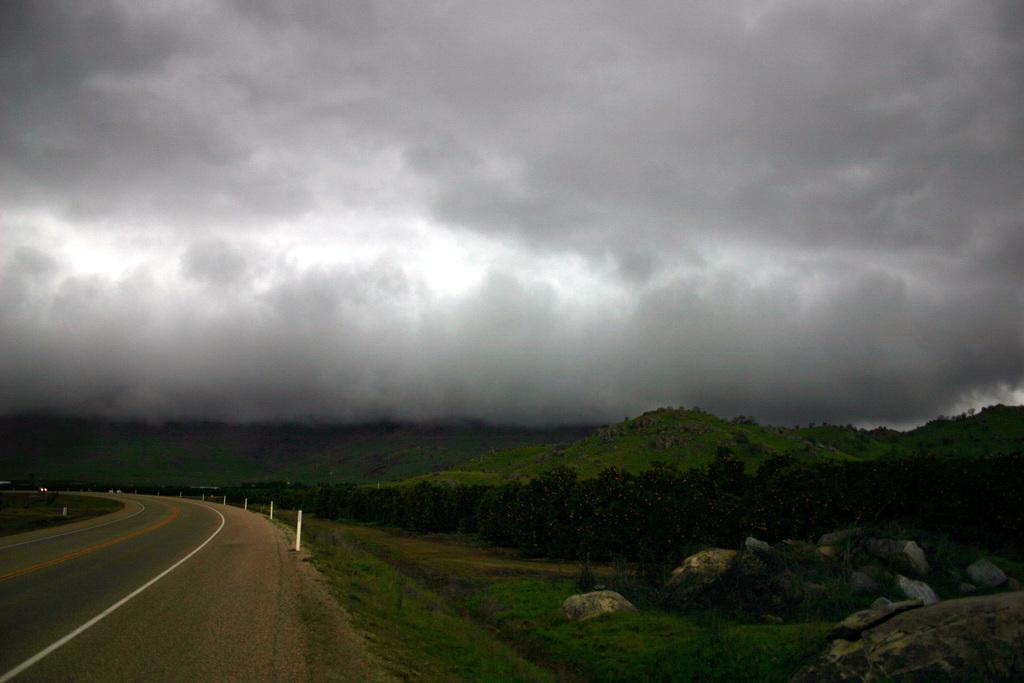What is the main feature of the image? There is a road in the image. What can be seen alongside the road? There are white-colored poles visible in the image. What type of vegetation is present in the image? There is grass visible in the image. What type of natural formations can be seen in the image? There are huge rocks and mountains in the image. What is visible in the background of the image? There are trees and the sky visible in the background of the image. What type of gate can be seen in the image? There is no gate present in the image. What type of country is depicted in the image? The image does not depict a specific country; it shows a road, poles, grass, rocks, mountains, trees, and the sky. 